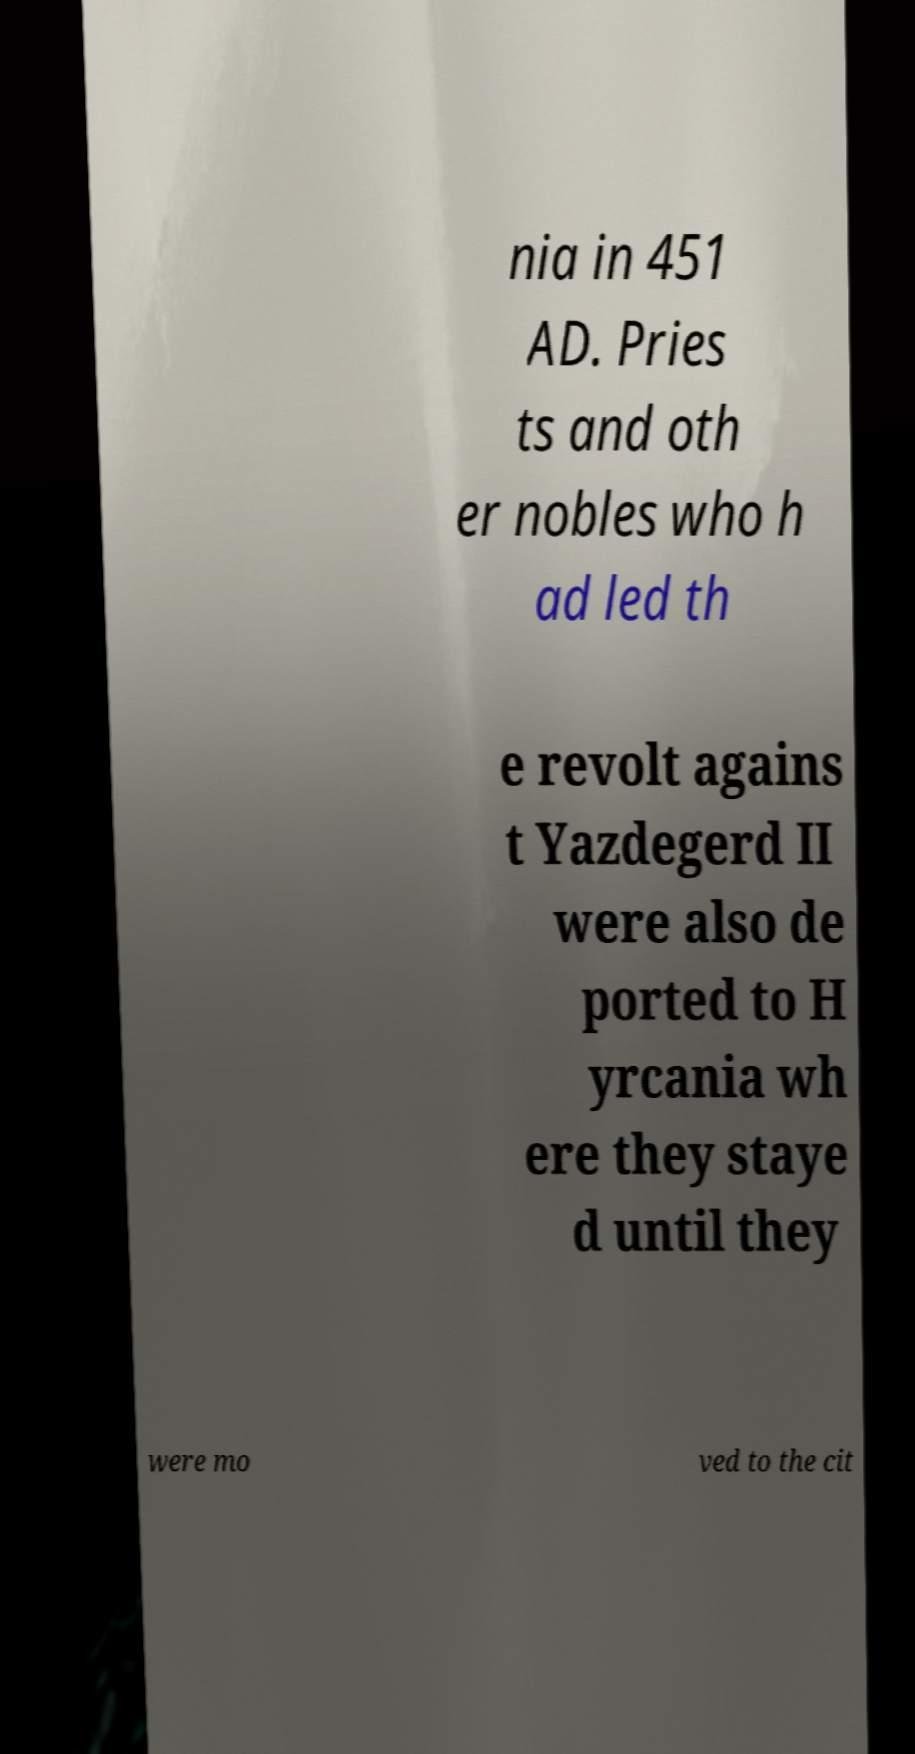Can you read and provide the text displayed in the image?This photo seems to have some interesting text. Can you extract and type it out for me? nia in 451 AD. Pries ts and oth er nobles who h ad led th e revolt agains t Yazdegerd II were also de ported to H yrcania wh ere they staye d until they were mo ved to the cit 